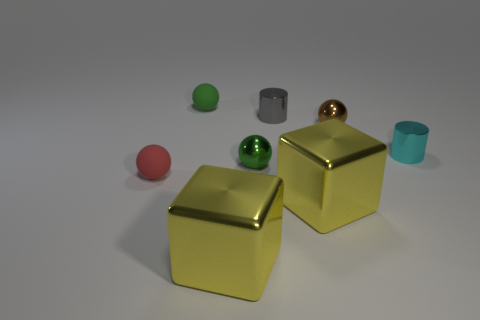Is there any other thing that has the same material as the small cyan cylinder?
Ensure brevity in your answer.  Yes. The brown sphere that is made of the same material as the tiny cyan cylinder is what size?
Your answer should be very brief. Small. Is the number of green things less than the number of red cylinders?
Your answer should be compact. No. What material is the brown ball that is the same size as the red rubber sphere?
Keep it short and to the point. Metal. Is the number of purple rubber spheres greater than the number of small red balls?
Make the answer very short. No. How many tiny things are left of the tiny green shiny ball and behind the brown ball?
Your answer should be compact. 1. Are there any other things that have the same size as the cyan thing?
Your response must be concise. Yes. Is the number of green things that are in front of the green rubber object greater than the number of cyan cylinders that are left of the red object?
Provide a short and direct response. Yes. What is the yellow block to the right of the gray shiny cylinder made of?
Make the answer very short. Metal. Is the shape of the tiny brown thing the same as the big yellow object that is on the right side of the gray metal cylinder?
Give a very brief answer. No. 